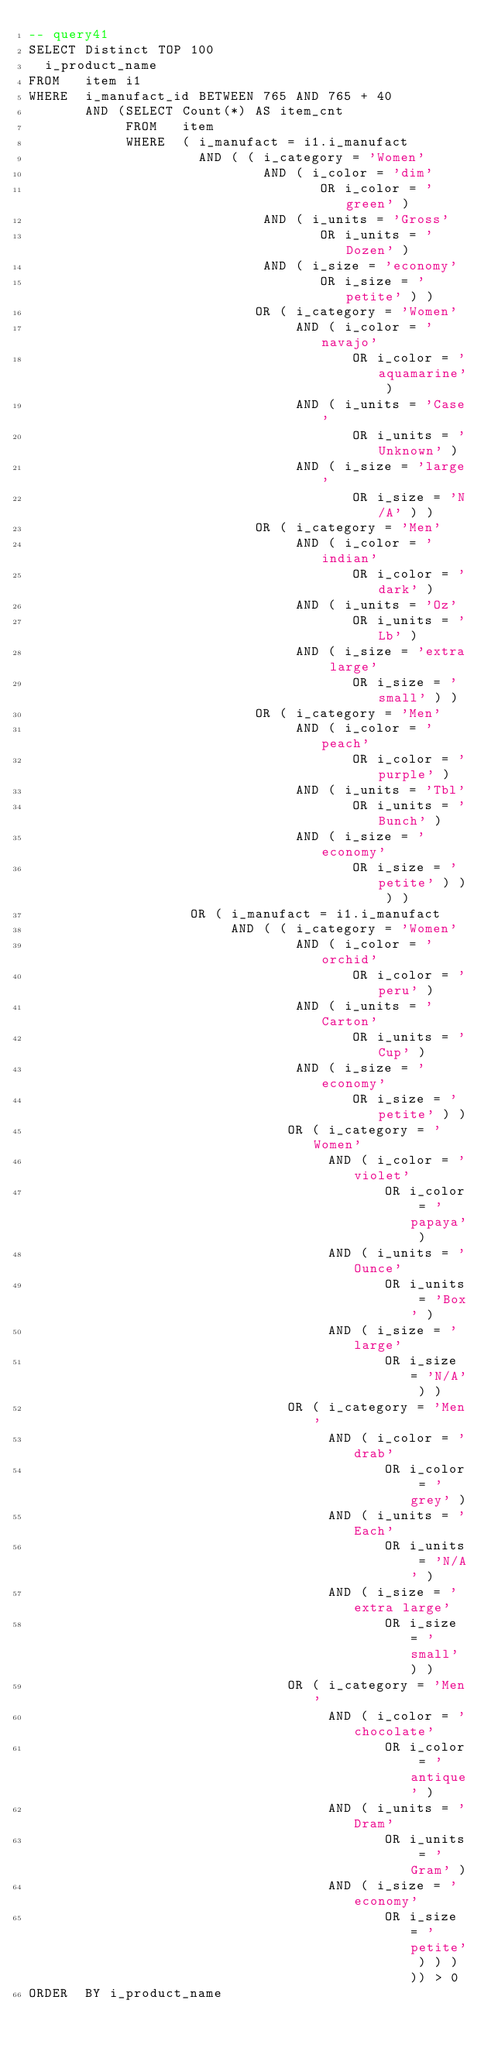<code> <loc_0><loc_0><loc_500><loc_500><_SQL_>-- query41
SELECT Distinct TOP 100
  i_product_name
FROM   item i1 
WHERE  i_manufact_id BETWEEN 765 AND 765 + 40 
       AND (SELECT Count(*) AS item_cnt 
            FROM   item 
            WHERE  ( i_manufact = i1.i_manufact 
                     AND ( ( i_category = 'Women' 
                             AND ( i_color = 'dim' 
                                    OR i_color = 'green' ) 
                             AND ( i_units = 'Gross' 
                                    OR i_units = 'Dozen' ) 
                             AND ( i_size = 'economy' 
                                    OR i_size = 'petite' ) ) 
                            OR ( i_category = 'Women' 
                                 AND ( i_color = 'navajo' 
                                        OR i_color = 'aquamarine' ) 
                                 AND ( i_units = 'Case' 
                                        OR i_units = 'Unknown' ) 
                                 AND ( i_size = 'large' 
                                        OR i_size = 'N/A' ) ) 
                            OR ( i_category = 'Men' 
                                 AND ( i_color = 'indian' 
                                        OR i_color = 'dark' ) 
                                 AND ( i_units = 'Oz' 
                                        OR i_units = 'Lb' ) 
                                 AND ( i_size = 'extra large' 
                                        OR i_size = 'small' ) ) 
                            OR ( i_category = 'Men' 
                                 AND ( i_color = 'peach' 
                                        OR i_color = 'purple' ) 
                                 AND ( i_units = 'Tbl' 
                                        OR i_units = 'Bunch' ) 
                                 AND ( i_size = 'economy' 
                                        OR i_size = 'petite' ) ) ) ) 
                    OR ( i_manufact = i1.i_manufact 
                         AND ( ( i_category = 'Women' 
                                 AND ( i_color = 'orchid' 
                                        OR i_color = 'peru' ) 
                                 AND ( i_units = 'Carton' 
                                        OR i_units = 'Cup' ) 
                                 AND ( i_size = 'economy' 
                                        OR i_size = 'petite' ) ) 
                                OR ( i_category = 'Women' 
                                     AND ( i_color = 'violet' 
                                            OR i_color = 'papaya' ) 
                                     AND ( i_units = 'Ounce' 
                                            OR i_units = 'Box' ) 
                                     AND ( i_size = 'large' 
                                            OR i_size = 'N/A' ) ) 
                                OR ( i_category = 'Men' 
                                     AND ( i_color = 'drab' 
                                            OR i_color = 'grey' ) 
                                     AND ( i_units = 'Each' 
                                            OR i_units = 'N/A' ) 
                                     AND ( i_size = 'extra large' 
                                            OR i_size = 'small' ) ) 
                                OR ( i_category = 'Men' 
                                     AND ( i_color = 'chocolate' 
                                            OR i_color = 'antique' ) 
                                     AND ( i_units = 'Dram' 
                                            OR i_units = 'Gram' ) 
                                     AND ( i_size = 'economy' 
                                            OR i_size = 'petite' ) ) ) )) > 0 
ORDER  BY i_product_name
</code> 